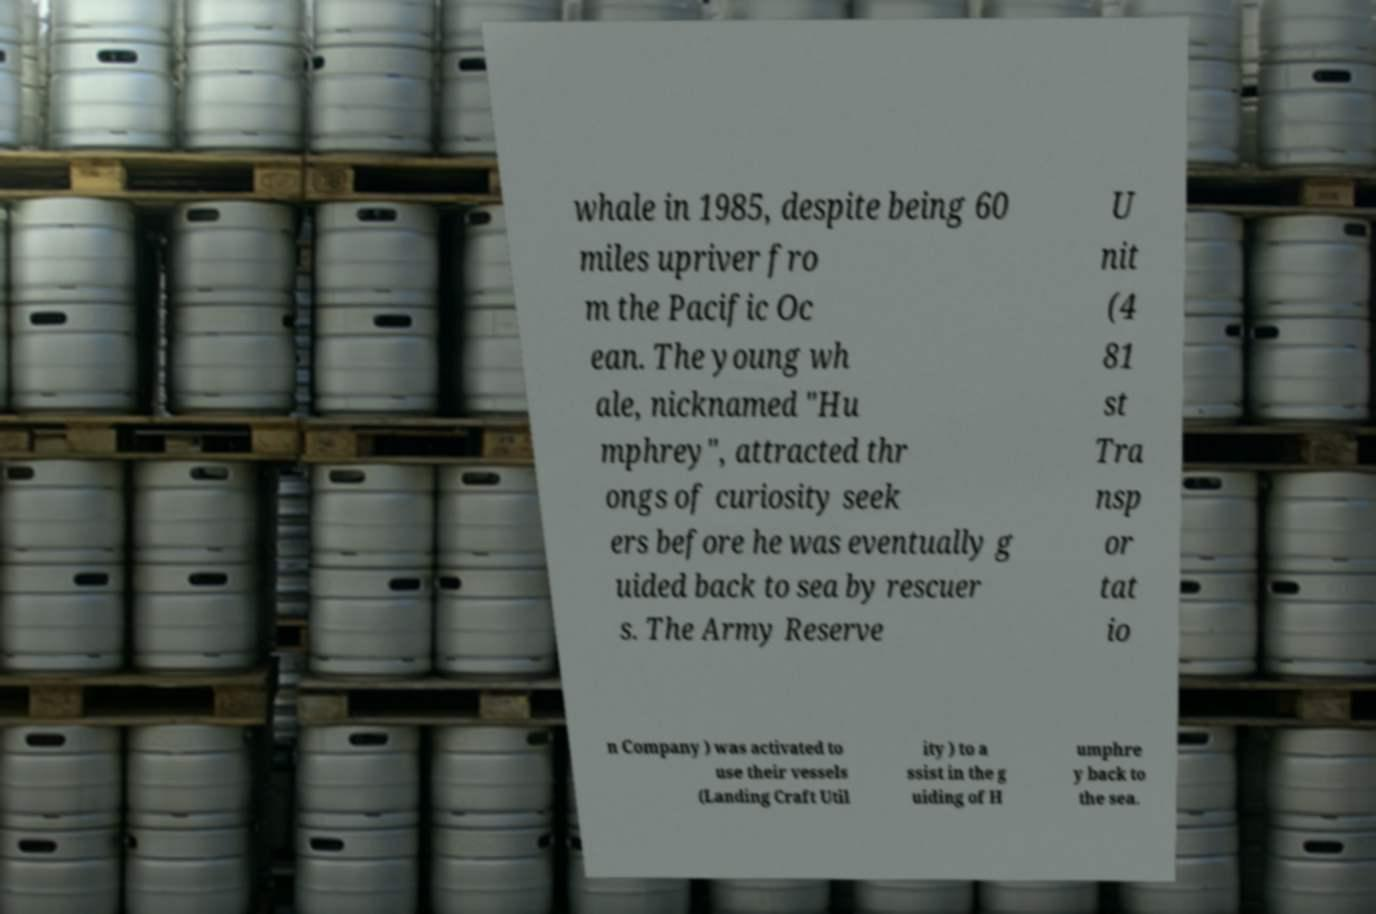I need the written content from this picture converted into text. Can you do that? whale in 1985, despite being 60 miles upriver fro m the Pacific Oc ean. The young wh ale, nicknamed "Hu mphrey", attracted thr ongs of curiosity seek ers before he was eventually g uided back to sea by rescuer s. The Army Reserve U nit (4 81 st Tra nsp or tat io n Company ) was activated to use their vessels (Landing Craft Util ity ) to a ssist in the g uiding of H umphre y back to the sea. 